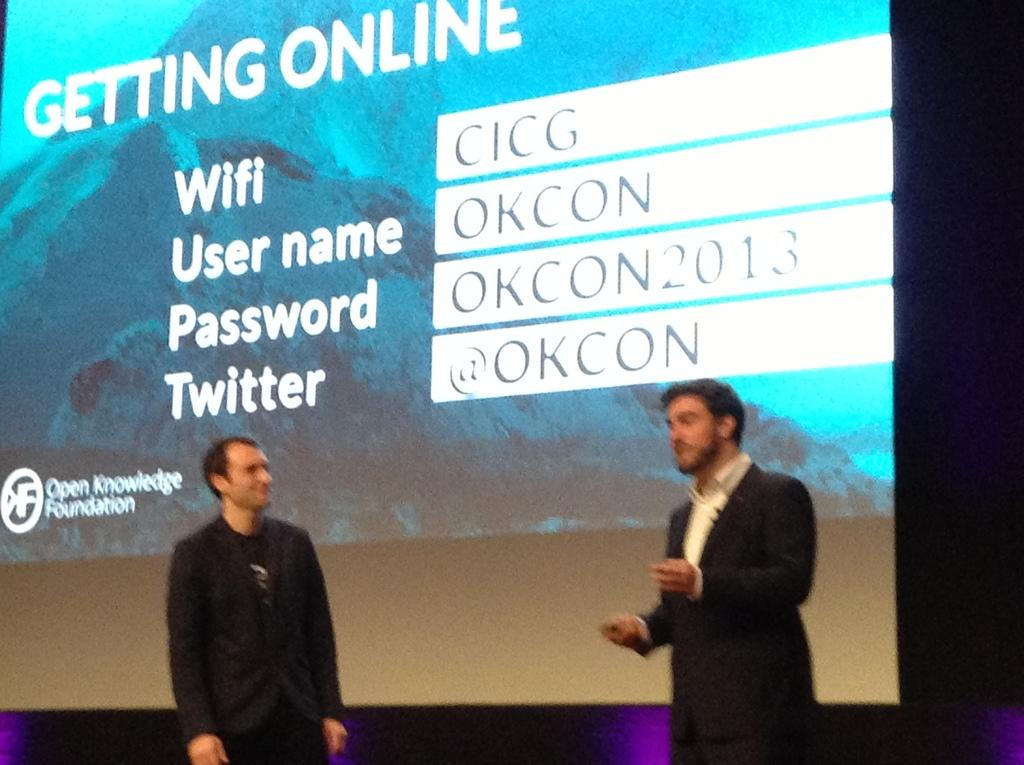How many people are in the image? There are two men in the image. What are the men doing in the image? The men are standing in the image. What are the men wearing in the image? The men are wearing formal suits in the image. What can be seen on the projector screen in the image? The content on the projector screen cannot be determined from the provided facts. What type of dust can be seen on the ice in the image? There is no ice or dust present in the image. 